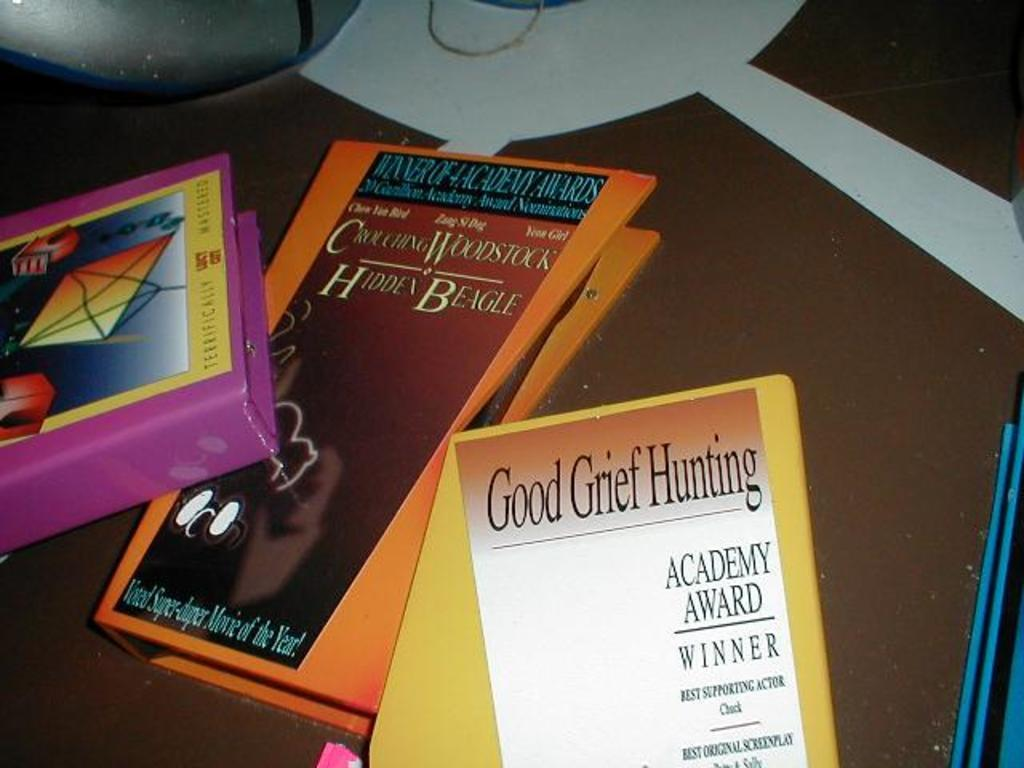<image>
Create a compact narrative representing the image presented. An orange binder has a cover with the phrase hidden beagle on it. 